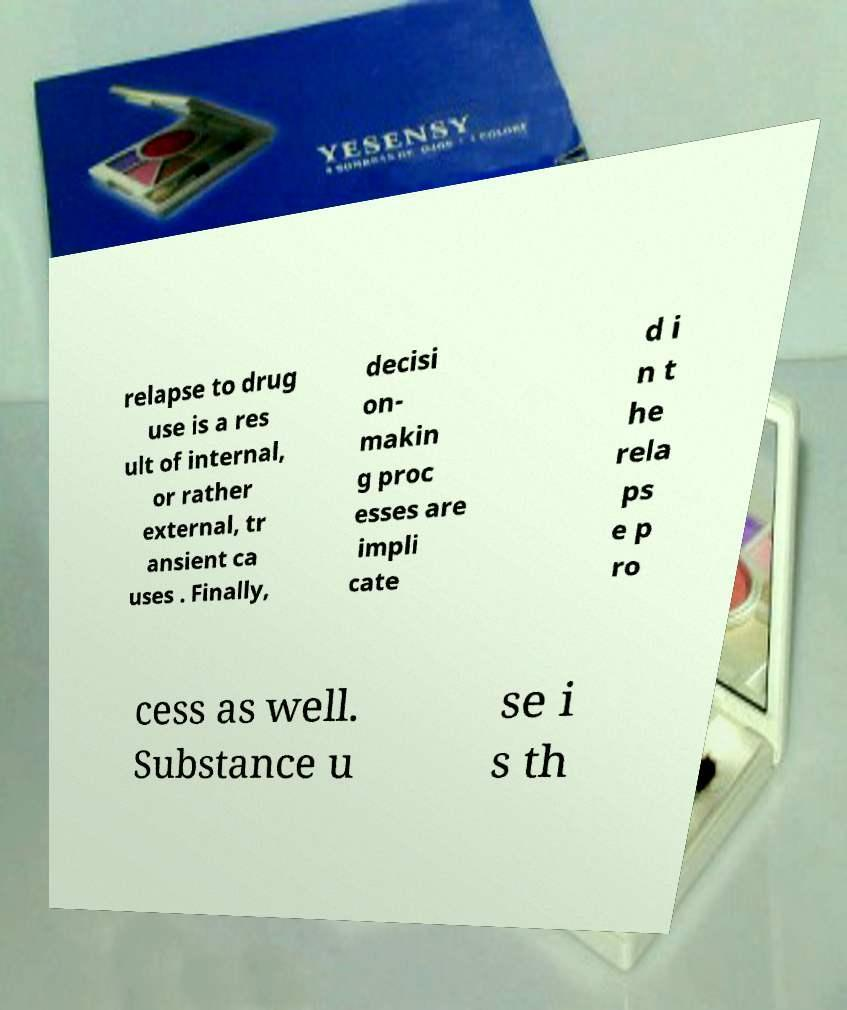For documentation purposes, I need the text within this image transcribed. Could you provide that? relapse to drug use is a res ult of internal, or rather external, tr ansient ca uses . Finally, decisi on- makin g proc esses are impli cate d i n t he rela ps e p ro cess as well. Substance u se i s th 